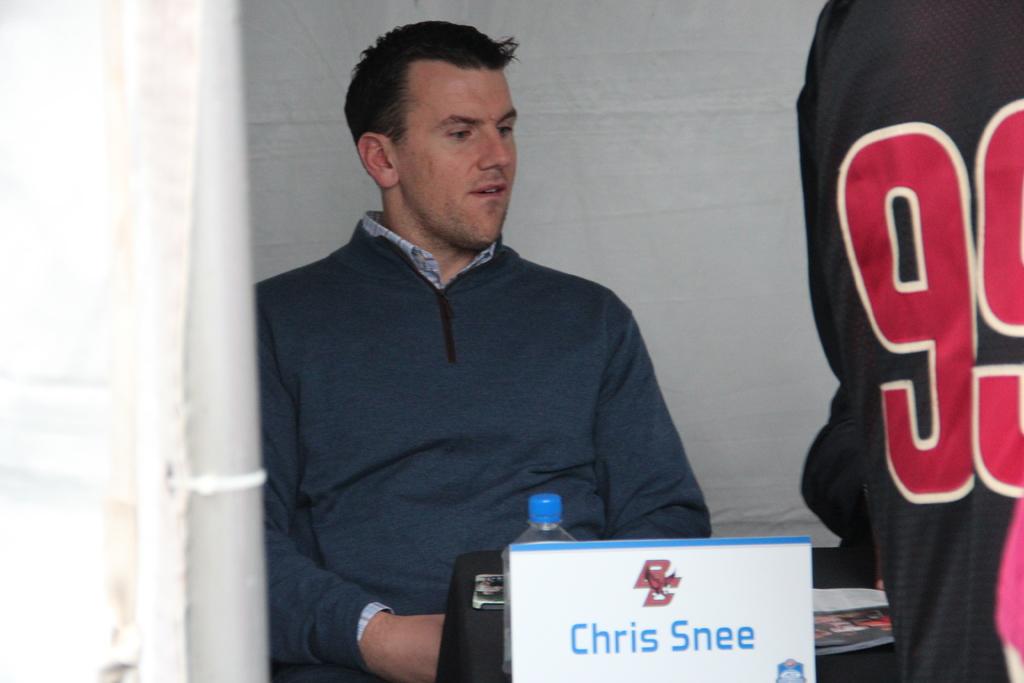What is this person's name?
Offer a terse response. Chris snee. What is the number on the jersey next to him?
Your answer should be compact. 99. 